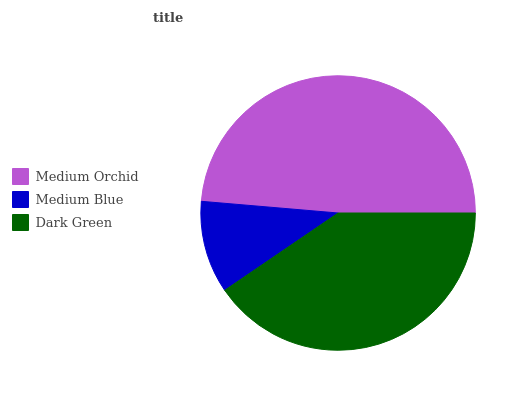Is Medium Blue the minimum?
Answer yes or no. Yes. Is Medium Orchid the maximum?
Answer yes or no. Yes. Is Dark Green the minimum?
Answer yes or no. No. Is Dark Green the maximum?
Answer yes or no. No. Is Dark Green greater than Medium Blue?
Answer yes or no. Yes. Is Medium Blue less than Dark Green?
Answer yes or no. Yes. Is Medium Blue greater than Dark Green?
Answer yes or no. No. Is Dark Green less than Medium Blue?
Answer yes or no. No. Is Dark Green the high median?
Answer yes or no. Yes. Is Dark Green the low median?
Answer yes or no. Yes. Is Medium Blue the high median?
Answer yes or no. No. Is Medium Orchid the low median?
Answer yes or no. No. 